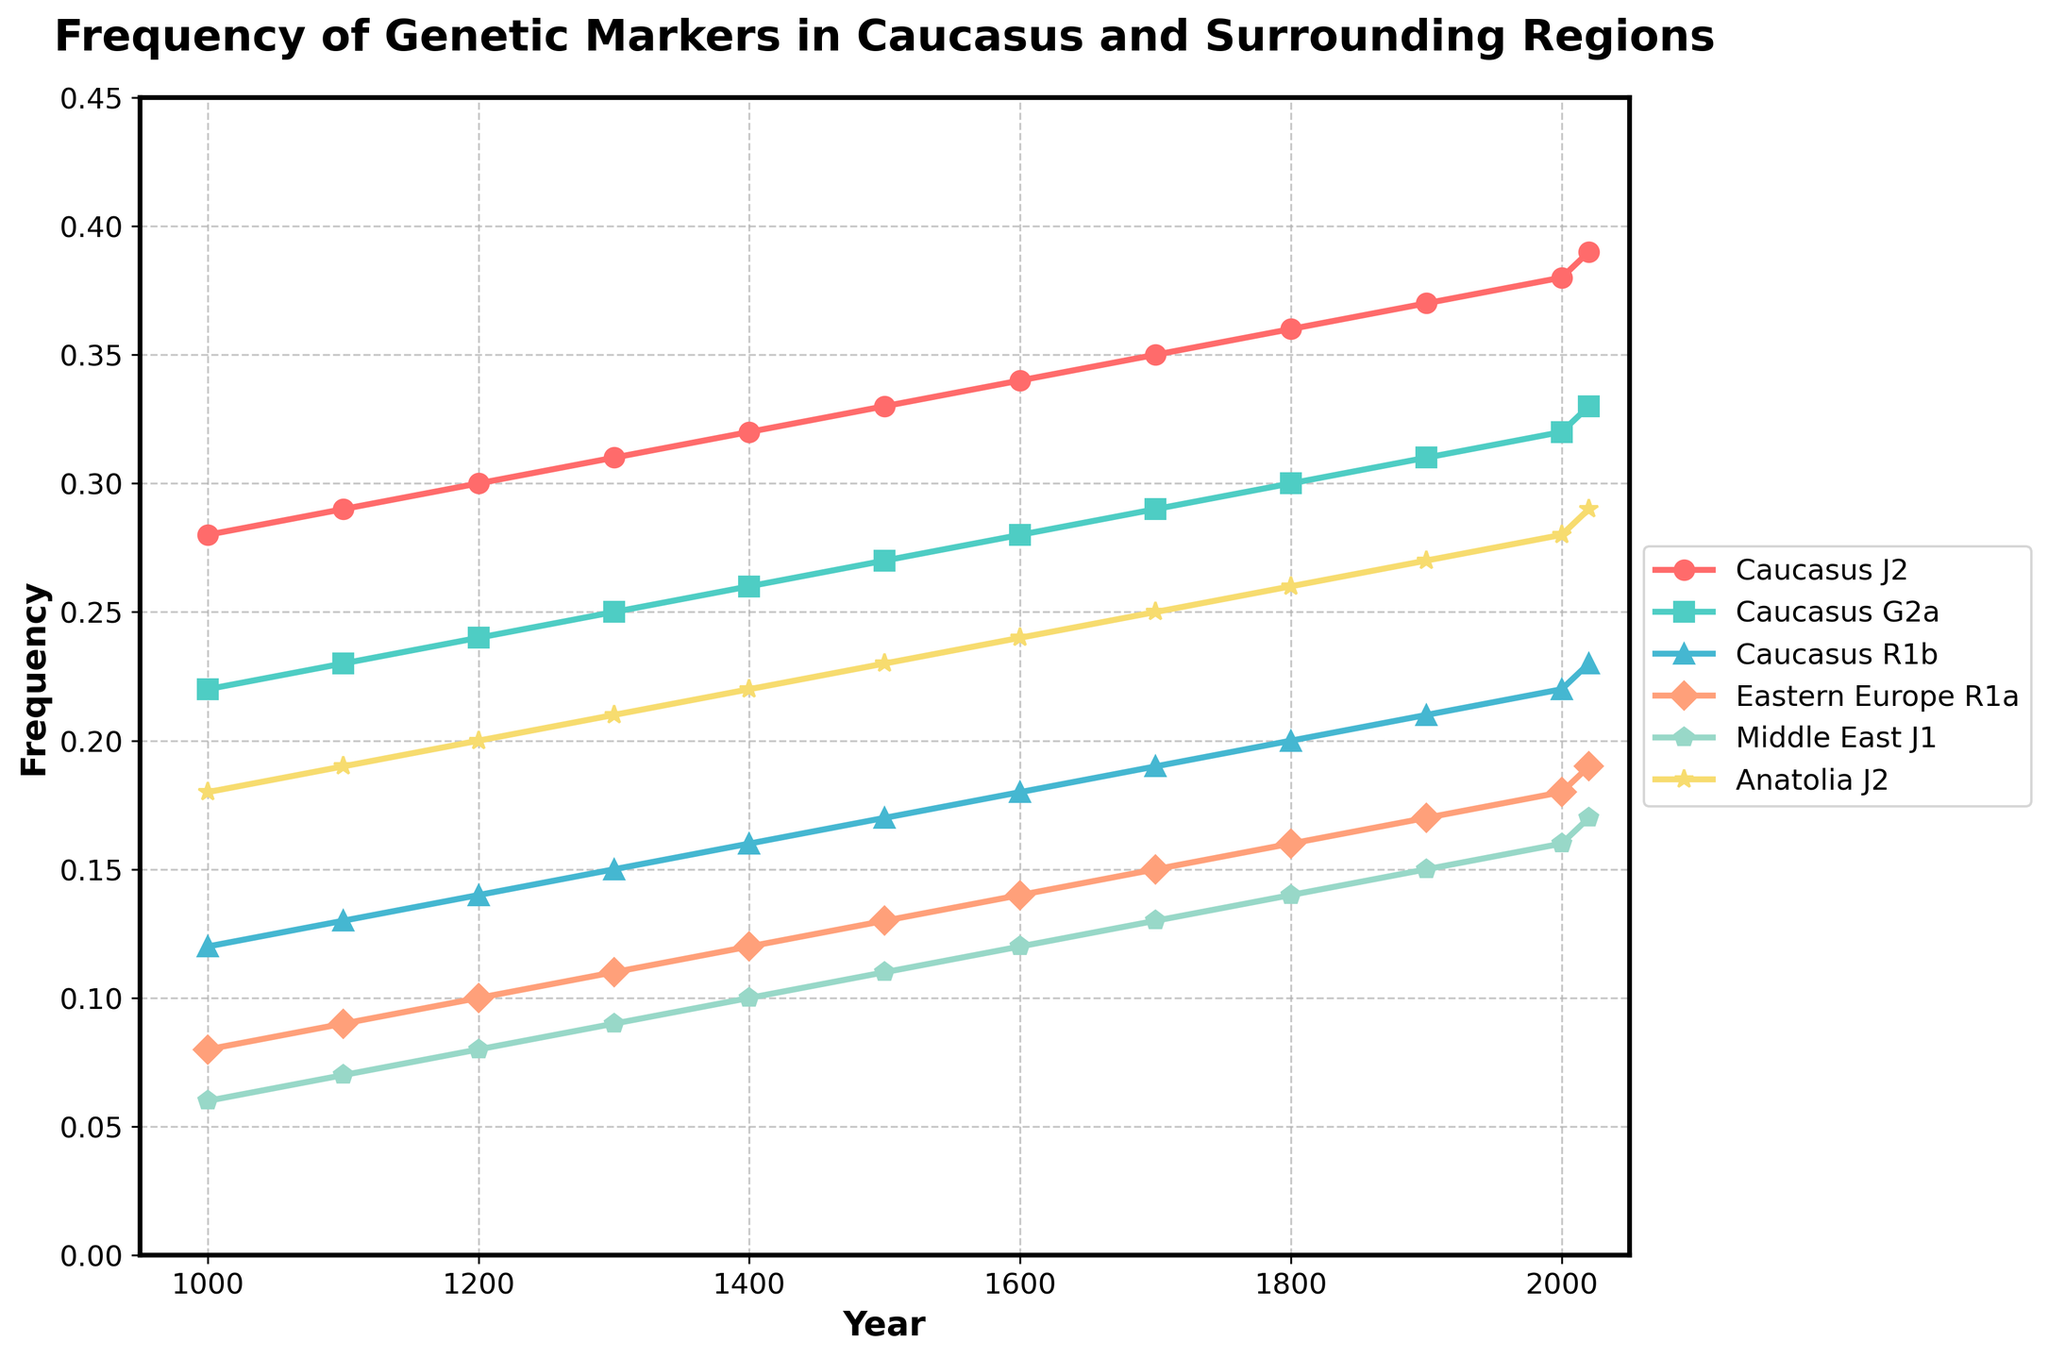What is the overall trend for the frequency of the J2 genetic marker in the Caucasus from 1000 CE to present? The line for the J2 genetic marker in the Caucasus steadily increases from a frequency of 0.28 in 1000 CE to 0.39 in 2020. This shows a consistent upward trend over time.
Answer: Consistent upward trend Which region had the highest frequency of the J2 genetic marker in 2020? In 2020, the Anatolia J2 marker line is at 0.29, whereas the Caucasus J2 marker is at 0.39. Hence, the Caucasus region has the highest frequency for J2 in 2020.
Answer: Caucasus What is the difference in the frequency of the G2a genetic marker in the Caucasus between the years 1300 and 1600? In 1300, the frequency of the G2a marker is 0.25, and in 1600, it is 0.28. The difference is 0.28 - 0.25 = 0.03.
Answer: 0.03 Between 1300 and 1600, which genetic marker in the Caucasus had the highest rate of increase? From 1300 to 1600, comparing the changes for J2 (0.34-0.31=0.03), G2a (0.28-0.25=0.03), and R1b (0.18-0.15=0.03), all markers increased at the same rate.
Answer: J2, G2a, R1b In 1400, how does the frequency of the R1a genetic marker in Eastern Europe compare to the R1b in the Caucasus? In 1400, the frequency of R1a in Eastern Europe is 0.12, and the frequency of R1b in the Caucasus is 0.16. R1b in the Caucasus is higher.
Answer: R1b in the Caucasus is higher What is the average frequency of the G2a genetic marker in the Caucasus over the 11 recorded data points? Sum of G2a frequencies: 0.22+0.23+0.24+...+0.33 = 3.03. Average = 3.03/11 ≈ 0.275.
Answer: 0.275 Which year marked the first instance where the frequency of the J2 marker in the Caucasus surpassed 0.30? The line for the J2 marker in the Caucasus first surpasses 0.30 in the year 1200.
Answer: 1200 How does the frequency of the J1 genetic marker in the Middle East in 2000 compare to the same marker in 2020? In 2000, the frequency of the Middle East J1 marker is 0.16, and in 2020 it is 0.17. The frequency increased by 0.01.
Answer: It increased by 0.01 What is the combined frequency of the J2 and G2a markers in the Caucasus in 1500? The frequency of J2 in 1500 is 0.33 and G2a is 0.27. Combined frequency = 0.33 + 0.27 = 0.60.
Answer: 0.60 Which genetic marker showed no change in frequency in the Middle East from 1000 CE to present? Each data point for the J1 marker in the Middle East shows a gradual increase from 0.06 in 1000 CE to 0.17 in 2020. Therefore, there is no marker that remained constant.
Answer: None 